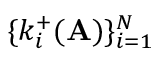Convert formula to latex. <formula><loc_0><loc_0><loc_500><loc_500>\{ k _ { i } ^ { + } ( A ) \} _ { i = 1 } ^ { N }</formula> 